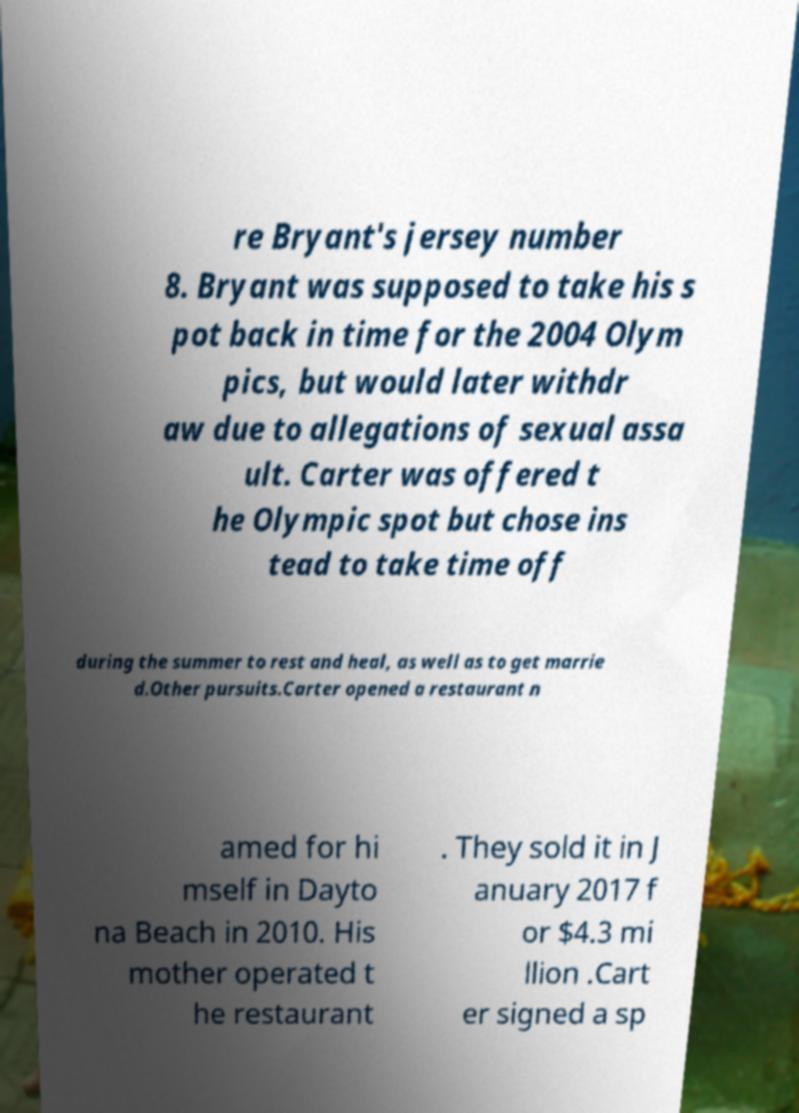Can you read and provide the text displayed in the image?This photo seems to have some interesting text. Can you extract and type it out for me? re Bryant's jersey number 8. Bryant was supposed to take his s pot back in time for the 2004 Olym pics, but would later withdr aw due to allegations of sexual assa ult. Carter was offered t he Olympic spot but chose ins tead to take time off during the summer to rest and heal, as well as to get marrie d.Other pursuits.Carter opened a restaurant n amed for hi mself in Dayto na Beach in 2010. His mother operated t he restaurant . They sold it in J anuary 2017 f or $4.3 mi llion .Cart er signed a sp 